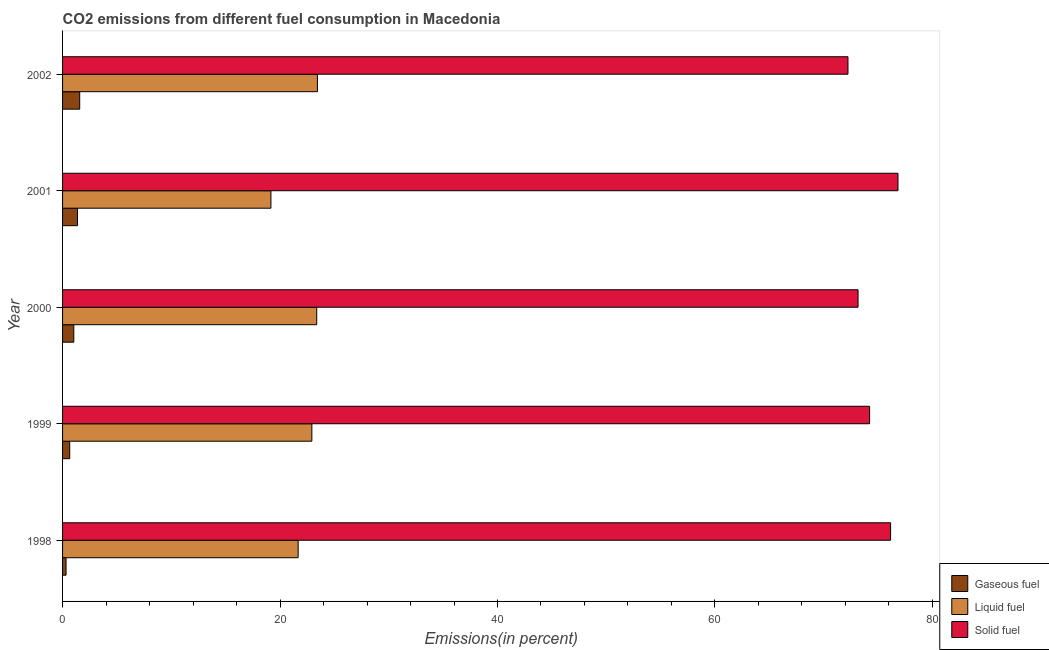How many groups of bars are there?
Provide a short and direct response. 5. Are the number of bars per tick equal to the number of legend labels?
Keep it short and to the point. Yes. What is the percentage of gaseous fuel emission in 2001?
Keep it short and to the point. 1.38. Across all years, what is the maximum percentage of liquid fuel emission?
Give a very brief answer. 23.44. Across all years, what is the minimum percentage of gaseous fuel emission?
Offer a terse response. 0.32. In which year was the percentage of gaseous fuel emission minimum?
Give a very brief answer. 1998. What is the total percentage of liquid fuel emission in the graph?
Keep it short and to the point. 110.57. What is the difference between the percentage of liquid fuel emission in 2000 and that in 2002?
Provide a short and direct response. -0.07. What is the difference between the percentage of liquid fuel emission in 2000 and the percentage of gaseous fuel emission in 2001?
Provide a short and direct response. 22. What is the average percentage of liquid fuel emission per year?
Your answer should be compact. 22.11. In the year 2000, what is the difference between the percentage of liquid fuel emission and percentage of solid fuel emission?
Your answer should be very brief. -49.79. What is the ratio of the percentage of solid fuel emission in 1999 to that in 2002?
Your answer should be very brief. 1.03. Is the percentage of liquid fuel emission in 1999 less than that in 2001?
Offer a terse response. No. Is the difference between the percentage of solid fuel emission in 1999 and 2001 greater than the difference between the percentage of liquid fuel emission in 1999 and 2001?
Your answer should be very brief. No. What is the difference between the highest and the second highest percentage of solid fuel emission?
Provide a short and direct response. 0.68. What is the difference between the highest and the lowest percentage of liquid fuel emission?
Offer a very short reply. 4.28. What does the 3rd bar from the top in 1998 represents?
Ensure brevity in your answer.  Gaseous fuel. What does the 3rd bar from the bottom in 2002 represents?
Provide a succinct answer. Solid fuel. Is it the case that in every year, the sum of the percentage of gaseous fuel emission and percentage of liquid fuel emission is greater than the percentage of solid fuel emission?
Keep it short and to the point. No. How many bars are there?
Offer a terse response. 15. Are all the bars in the graph horizontal?
Your answer should be compact. Yes. How many years are there in the graph?
Provide a short and direct response. 5. What is the difference between two consecutive major ticks on the X-axis?
Provide a succinct answer. 20. Where does the legend appear in the graph?
Offer a terse response. Bottom right. What is the title of the graph?
Your response must be concise. CO2 emissions from different fuel consumption in Macedonia. Does "Primary" appear as one of the legend labels in the graph?
Give a very brief answer. No. What is the label or title of the X-axis?
Offer a terse response. Emissions(in percent). What is the label or title of the Y-axis?
Give a very brief answer. Year. What is the Emissions(in percent) of Gaseous fuel in 1998?
Your response must be concise. 0.32. What is the Emissions(in percent) in Liquid fuel in 1998?
Your answer should be compact. 21.67. What is the Emissions(in percent) in Solid fuel in 1998?
Offer a terse response. 76.15. What is the Emissions(in percent) of Gaseous fuel in 1999?
Offer a terse response. 0.66. What is the Emissions(in percent) in Liquid fuel in 1999?
Offer a terse response. 22.93. What is the Emissions(in percent) of Solid fuel in 1999?
Offer a very short reply. 74.23. What is the Emissions(in percent) of Gaseous fuel in 2000?
Make the answer very short. 1.03. What is the Emissions(in percent) of Liquid fuel in 2000?
Your answer should be compact. 23.37. What is the Emissions(in percent) of Solid fuel in 2000?
Your answer should be very brief. 73.16. What is the Emissions(in percent) in Gaseous fuel in 2001?
Keep it short and to the point. 1.38. What is the Emissions(in percent) of Liquid fuel in 2001?
Offer a terse response. 19.16. What is the Emissions(in percent) in Solid fuel in 2001?
Your answer should be very brief. 76.83. What is the Emissions(in percent) in Gaseous fuel in 2002?
Ensure brevity in your answer.  1.58. What is the Emissions(in percent) in Liquid fuel in 2002?
Provide a succinct answer. 23.44. What is the Emissions(in percent) in Solid fuel in 2002?
Keep it short and to the point. 72.23. Across all years, what is the maximum Emissions(in percent) in Gaseous fuel?
Provide a short and direct response. 1.58. Across all years, what is the maximum Emissions(in percent) of Liquid fuel?
Give a very brief answer. 23.44. Across all years, what is the maximum Emissions(in percent) in Solid fuel?
Make the answer very short. 76.83. Across all years, what is the minimum Emissions(in percent) of Gaseous fuel?
Ensure brevity in your answer.  0.32. Across all years, what is the minimum Emissions(in percent) of Liquid fuel?
Give a very brief answer. 19.16. Across all years, what is the minimum Emissions(in percent) in Solid fuel?
Offer a very short reply. 72.23. What is the total Emissions(in percent) in Gaseous fuel in the graph?
Ensure brevity in your answer.  4.96. What is the total Emissions(in percent) in Liquid fuel in the graph?
Provide a short and direct response. 110.57. What is the total Emissions(in percent) of Solid fuel in the graph?
Offer a very short reply. 372.61. What is the difference between the Emissions(in percent) of Gaseous fuel in 1998 and that in 1999?
Provide a succinct answer. -0.34. What is the difference between the Emissions(in percent) of Liquid fuel in 1998 and that in 1999?
Ensure brevity in your answer.  -1.26. What is the difference between the Emissions(in percent) in Solid fuel in 1998 and that in 1999?
Provide a short and direct response. 1.93. What is the difference between the Emissions(in percent) of Gaseous fuel in 1998 and that in 2000?
Ensure brevity in your answer.  -0.71. What is the difference between the Emissions(in percent) in Liquid fuel in 1998 and that in 2000?
Your response must be concise. -1.71. What is the difference between the Emissions(in percent) of Solid fuel in 1998 and that in 2000?
Make the answer very short. 2.99. What is the difference between the Emissions(in percent) of Gaseous fuel in 1998 and that in 2001?
Make the answer very short. -1.06. What is the difference between the Emissions(in percent) of Liquid fuel in 1998 and that in 2001?
Offer a very short reply. 2.5. What is the difference between the Emissions(in percent) in Solid fuel in 1998 and that in 2001?
Make the answer very short. -0.68. What is the difference between the Emissions(in percent) of Gaseous fuel in 1998 and that in 2002?
Your answer should be compact. -1.26. What is the difference between the Emissions(in percent) in Liquid fuel in 1998 and that in 2002?
Keep it short and to the point. -1.77. What is the difference between the Emissions(in percent) of Solid fuel in 1998 and that in 2002?
Your response must be concise. 3.92. What is the difference between the Emissions(in percent) of Gaseous fuel in 1999 and that in 2000?
Offer a very short reply. -0.38. What is the difference between the Emissions(in percent) of Liquid fuel in 1999 and that in 2000?
Ensure brevity in your answer.  -0.45. What is the difference between the Emissions(in percent) in Solid fuel in 1999 and that in 2000?
Your answer should be compact. 1.06. What is the difference between the Emissions(in percent) of Gaseous fuel in 1999 and that in 2001?
Provide a succinct answer. -0.72. What is the difference between the Emissions(in percent) in Liquid fuel in 1999 and that in 2001?
Your answer should be very brief. 3.77. What is the difference between the Emissions(in percent) in Solid fuel in 1999 and that in 2001?
Keep it short and to the point. -2.61. What is the difference between the Emissions(in percent) of Gaseous fuel in 1999 and that in 2002?
Give a very brief answer. -0.92. What is the difference between the Emissions(in percent) of Liquid fuel in 1999 and that in 2002?
Your answer should be compact. -0.51. What is the difference between the Emissions(in percent) in Solid fuel in 1999 and that in 2002?
Your response must be concise. 1.99. What is the difference between the Emissions(in percent) in Gaseous fuel in 2000 and that in 2001?
Your response must be concise. -0.34. What is the difference between the Emissions(in percent) of Liquid fuel in 2000 and that in 2001?
Ensure brevity in your answer.  4.21. What is the difference between the Emissions(in percent) of Solid fuel in 2000 and that in 2001?
Your answer should be very brief. -3.67. What is the difference between the Emissions(in percent) of Gaseous fuel in 2000 and that in 2002?
Keep it short and to the point. -0.54. What is the difference between the Emissions(in percent) in Liquid fuel in 2000 and that in 2002?
Your answer should be very brief. -0.07. What is the difference between the Emissions(in percent) of Solid fuel in 2000 and that in 2002?
Offer a terse response. 0.93. What is the difference between the Emissions(in percent) in Gaseous fuel in 2001 and that in 2002?
Provide a succinct answer. -0.2. What is the difference between the Emissions(in percent) in Liquid fuel in 2001 and that in 2002?
Offer a very short reply. -4.28. What is the difference between the Emissions(in percent) in Solid fuel in 2001 and that in 2002?
Provide a short and direct response. 4.6. What is the difference between the Emissions(in percent) of Gaseous fuel in 1998 and the Emissions(in percent) of Liquid fuel in 1999?
Give a very brief answer. -22.61. What is the difference between the Emissions(in percent) of Gaseous fuel in 1998 and the Emissions(in percent) of Solid fuel in 1999?
Give a very brief answer. -73.91. What is the difference between the Emissions(in percent) of Liquid fuel in 1998 and the Emissions(in percent) of Solid fuel in 1999?
Provide a succinct answer. -52.56. What is the difference between the Emissions(in percent) of Gaseous fuel in 1998 and the Emissions(in percent) of Liquid fuel in 2000?
Your response must be concise. -23.05. What is the difference between the Emissions(in percent) of Gaseous fuel in 1998 and the Emissions(in percent) of Solid fuel in 2000?
Your answer should be very brief. -72.84. What is the difference between the Emissions(in percent) in Liquid fuel in 1998 and the Emissions(in percent) in Solid fuel in 2000?
Give a very brief answer. -51.49. What is the difference between the Emissions(in percent) in Gaseous fuel in 1998 and the Emissions(in percent) in Liquid fuel in 2001?
Your answer should be very brief. -18.84. What is the difference between the Emissions(in percent) in Gaseous fuel in 1998 and the Emissions(in percent) in Solid fuel in 2001?
Make the answer very short. -76.51. What is the difference between the Emissions(in percent) in Liquid fuel in 1998 and the Emissions(in percent) in Solid fuel in 2001?
Provide a short and direct response. -55.17. What is the difference between the Emissions(in percent) in Gaseous fuel in 1998 and the Emissions(in percent) in Liquid fuel in 2002?
Keep it short and to the point. -23.12. What is the difference between the Emissions(in percent) in Gaseous fuel in 1998 and the Emissions(in percent) in Solid fuel in 2002?
Keep it short and to the point. -71.91. What is the difference between the Emissions(in percent) in Liquid fuel in 1998 and the Emissions(in percent) in Solid fuel in 2002?
Ensure brevity in your answer.  -50.57. What is the difference between the Emissions(in percent) of Gaseous fuel in 1999 and the Emissions(in percent) of Liquid fuel in 2000?
Your response must be concise. -22.72. What is the difference between the Emissions(in percent) in Gaseous fuel in 1999 and the Emissions(in percent) in Solid fuel in 2000?
Your answer should be compact. -72.5. What is the difference between the Emissions(in percent) in Liquid fuel in 1999 and the Emissions(in percent) in Solid fuel in 2000?
Your answer should be very brief. -50.23. What is the difference between the Emissions(in percent) in Gaseous fuel in 1999 and the Emissions(in percent) in Liquid fuel in 2001?
Offer a terse response. -18.51. What is the difference between the Emissions(in percent) in Gaseous fuel in 1999 and the Emissions(in percent) in Solid fuel in 2001?
Your answer should be compact. -76.18. What is the difference between the Emissions(in percent) in Liquid fuel in 1999 and the Emissions(in percent) in Solid fuel in 2001?
Offer a very short reply. -53.91. What is the difference between the Emissions(in percent) in Gaseous fuel in 1999 and the Emissions(in percent) in Liquid fuel in 2002?
Offer a very short reply. -22.78. What is the difference between the Emissions(in percent) of Gaseous fuel in 1999 and the Emissions(in percent) of Solid fuel in 2002?
Keep it short and to the point. -71.58. What is the difference between the Emissions(in percent) in Liquid fuel in 1999 and the Emissions(in percent) in Solid fuel in 2002?
Offer a terse response. -49.31. What is the difference between the Emissions(in percent) of Gaseous fuel in 2000 and the Emissions(in percent) of Liquid fuel in 2001?
Your answer should be very brief. -18.13. What is the difference between the Emissions(in percent) in Gaseous fuel in 2000 and the Emissions(in percent) in Solid fuel in 2001?
Provide a short and direct response. -75.8. What is the difference between the Emissions(in percent) of Liquid fuel in 2000 and the Emissions(in percent) of Solid fuel in 2001?
Provide a short and direct response. -53.46. What is the difference between the Emissions(in percent) of Gaseous fuel in 2000 and the Emissions(in percent) of Liquid fuel in 2002?
Ensure brevity in your answer.  -22.41. What is the difference between the Emissions(in percent) of Gaseous fuel in 2000 and the Emissions(in percent) of Solid fuel in 2002?
Your response must be concise. -71.2. What is the difference between the Emissions(in percent) of Liquid fuel in 2000 and the Emissions(in percent) of Solid fuel in 2002?
Your answer should be very brief. -48.86. What is the difference between the Emissions(in percent) of Gaseous fuel in 2001 and the Emissions(in percent) of Liquid fuel in 2002?
Your answer should be very brief. -22.07. What is the difference between the Emissions(in percent) of Gaseous fuel in 2001 and the Emissions(in percent) of Solid fuel in 2002?
Offer a terse response. -70.86. What is the difference between the Emissions(in percent) in Liquid fuel in 2001 and the Emissions(in percent) in Solid fuel in 2002?
Your answer should be compact. -53.07. What is the average Emissions(in percent) in Gaseous fuel per year?
Ensure brevity in your answer.  0.99. What is the average Emissions(in percent) of Liquid fuel per year?
Keep it short and to the point. 22.11. What is the average Emissions(in percent) of Solid fuel per year?
Offer a very short reply. 74.52. In the year 1998, what is the difference between the Emissions(in percent) in Gaseous fuel and Emissions(in percent) in Liquid fuel?
Ensure brevity in your answer.  -21.35. In the year 1998, what is the difference between the Emissions(in percent) of Gaseous fuel and Emissions(in percent) of Solid fuel?
Your response must be concise. -75.83. In the year 1998, what is the difference between the Emissions(in percent) in Liquid fuel and Emissions(in percent) in Solid fuel?
Your response must be concise. -54.49. In the year 1999, what is the difference between the Emissions(in percent) in Gaseous fuel and Emissions(in percent) in Liquid fuel?
Your response must be concise. -22.27. In the year 1999, what is the difference between the Emissions(in percent) in Gaseous fuel and Emissions(in percent) in Solid fuel?
Provide a succinct answer. -73.57. In the year 1999, what is the difference between the Emissions(in percent) of Liquid fuel and Emissions(in percent) of Solid fuel?
Provide a short and direct response. -51.3. In the year 2000, what is the difference between the Emissions(in percent) in Gaseous fuel and Emissions(in percent) in Liquid fuel?
Your answer should be compact. -22.34. In the year 2000, what is the difference between the Emissions(in percent) of Gaseous fuel and Emissions(in percent) of Solid fuel?
Provide a succinct answer. -72.13. In the year 2000, what is the difference between the Emissions(in percent) of Liquid fuel and Emissions(in percent) of Solid fuel?
Give a very brief answer. -49.79. In the year 2001, what is the difference between the Emissions(in percent) in Gaseous fuel and Emissions(in percent) in Liquid fuel?
Give a very brief answer. -17.79. In the year 2001, what is the difference between the Emissions(in percent) in Gaseous fuel and Emissions(in percent) in Solid fuel?
Offer a very short reply. -75.46. In the year 2001, what is the difference between the Emissions(in percent) in Liquid fuel and Emissions(in percent) in Solid fuel?
Give a very brief answer. -57.67. In the year 2002, what is the difference between the Emissions(in percent) of Gaseous fuel and Emissions(in percent) of Liquid fuel?
Your answer should be compact. -21.86. In the year 2002, what is the difference between the Emissions(in percent) of Gaseous fuel and Emissions(in percent) of Solid fuel?
Provide a succinct answer. -70.66. In the year 2002, what is the difference between the Emissions(in percent) of Liquid fuel and Emissions(in percent) of Solid fuel?
Your answer should be very brief. -48.79. What is the ratio of the Emissions(in percent) of Gaseous fuel in 1998 to that in 1999?
Your response must be concise. 0.49. What is the ratio of the Emissions(in percent) in Liquid fuel in 1998 to that in 1999?
Offer a very short reply. 0.94. What is the ratio of the Emissions(in percent) in Gaseous fuel in 1998 to that in 2000?
Provide a succinct answer. 0.31. What is the ratio of the Emissions(in percent) in Liquid fuel in 1998 to that in 2000?
Provide a short and direct response. 0.93. What is the ratio of the Emissions(in percent) of Solid fuel in 1998 to that in 2000?
Your answer should be very brief. 1.04. What is the ratio of the Emissions(in percent) of Gaseous fuel in 1998 to that in 2001?
Provide a short and direct response. 0.23. What is the ratio of the Emissions(in percent) in Liquid fuel in 1998 to that in 2001?
Your answer should be very brief. 1.13. What is the ratio of the Emissions(in percent) of Solid fuel in 1998 to that in 2001?
Ensure brevity in your answer.  0.99. What is the ratio of the Emissions(in percent) in Gaseous fuel in 1998 to that in 2002?
Offer a terse response. 0.2. What is the ratio of the Emissions(in percent) of Liquid fuel in 1998 to that in 2002?
Offer a terse response. 0.92. What is the ratio of the Emissions(in percent) of Solid fuel in 1998 to that in 2002?
Provide a succinct answer. 1.05. What is the ratio of the Emissions(in percent) of Gaseous fuel in 1999 to that in 2000?
Your response must be concise. 0.64. What is the ratio of the Emissions(in percent) in Liquid fuel in 1999 to that in 2000?
Give a very brief answer. 0.98. What is the ratio of the Emissions(in percent) in Solid fuel in 1999 to that in 2000?
Provide a succinct answer. 1.01. What is the ratio of the Emissions(in percent) in Gaseous fuel in 1999 to that in 2001?
Your answer should be very brief. 0.48. What is the ratio of the Emissions(in percent) of Liquid fuel in 1999 to that in 2001?
Offer a very short reply. 1.2. What is the ratio of the Emissions(in percent) in Solid fuel in 1999 to that in 2001?
Keep it short and to the point. 0.97. What is the ratio of the Emissions(in percent) of Gaseous fuel in 1999 to that in 2002?
Give a very brief answer. 0.42. What is the ratio of the Emissions(in percent) of Liquid fuel in 1999 to that in 2002?
Your response must be concise. 0.98. What is the ratio of the Emissions(in percent) of Solid fuel in 1999 to that in 2002?
Give a very brief answer. 1.03. What is the ratio of the Emissions(in percent) of Gaseous fuel in 2000 to that in 2001?
Provide a succinct answer. 0.75. What is the ratio of the Emissions(in percent) of Liquid fuel in 2000 to that in 2001?
Your response must be concise. 1.22. What is the ratio of the Emissions(in percent) in Solid fuel in 2000 to that in 2001?
Provide a short and direct response. 0.95. What is the ratio of the Emissions(in percent) in Gaseous fuel in 2000 to that in 2002?
Your answer should be very brief. 0.66. What is the ratio of the Emissions(in percent) of Liquid fuel in 2000 to that in 2002?
Provide a short and direct response. 1. What is the ratio of the Emissions(in percent) of Solid fuel in 2000 to that in 2002?
Your response must be concise. 1.01. What is the ratio of the Emissions(in percent) in Gaseous fuel in 2001 to that in 2002?
Make the answer very short. 0.87. What is the ratio of the Emissions(in percent) of Liquid fuel in 2001 to that in 2002?
Make the answer very short. 0.82. What is the ratio of the Emissions(in percent) of Solid fuel in 2001 to that in 2002?
Keep it short and to the point. 1.06. What is the difference between the highest and the second highest Emissions(in percent) of Gaseous fuel?
Offer a terse response. 0.2. What is the difference between the highest and the second highest Emissions(in percent) in Liquid fuel?
Keep it short and to the point. 0.07. What is the difference between the highest and the second highest Emissions(in percent) in Solid fuel?
Make the answer very short. 0.68. What is the difference between the highest and the lowest Emissions(in percent) of Gaseous fuel?
Provide a short and direct response. 1.26. What is the difference between the highest and the lowest Emissions(in percent) of Liquid fuel?
Offer a terse response. 4.28. What is the difference between the highest and the lowest Emissions(in percent) of Solid fuel?
Your response must be concise. 4.6. 